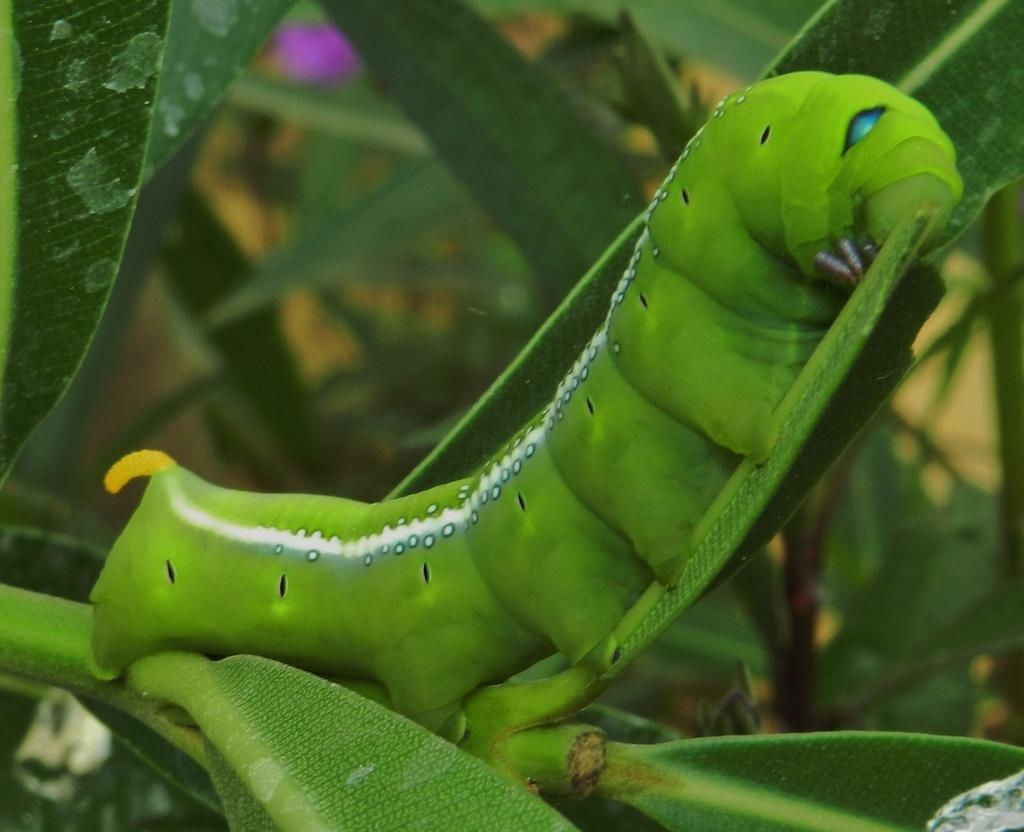What is the main subject of the image? There is a caterpillar on a plant in the image. Can you describe the plant that the caterpillar is on? Unfortunately, the facts provided do not give enough detail about the plant. However, we can confirm that there is a plant in the image. What can be seen in the background of the image? There are plants visible in the background of the image. How does the caterpillar help the friend with their cough in the image? There is no mention of a cough or a friend in the image. The image only features a caterpillar on a plant and plants in the background. 